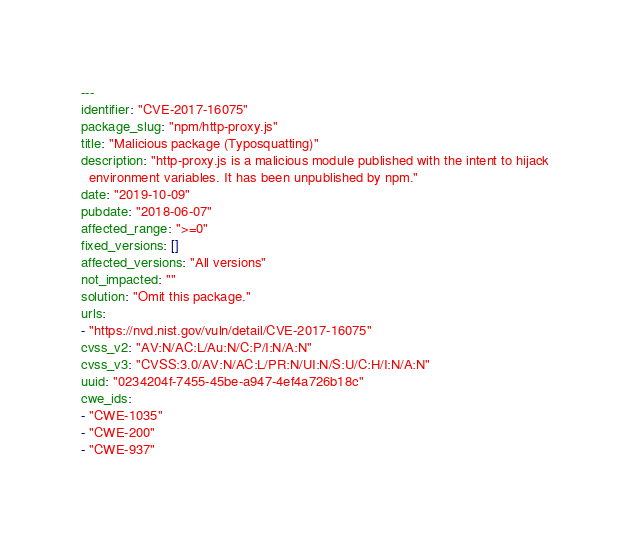Convert code to text. <code><loc_0><loc_0><loc_500><loc_500><_YAML_>---
identifier: "CVE-2017-16075"
package_slug: "npm/http-proxy.js"
title: "Malicious package (Typosquatting)"
description: "http-proxy.js is a malicious module published with the intent to hijack
  environment variables. It has been unpublished by npm."
date: "2019-10-09"
pubdate: "2018-06-07"
affected_range: ">=0"
fixed_versions: []
affected_versions: "All versions"
not_impacted: ""
solution: "Omit this package."
urls:
- "https://nvd.nist.gov/vuln/detail/CVE-2017-16075"
cvss_v2: "AV:N/AC:L/Au:N/C:P/I:N/A:N"
cvss_v3: "CVSS:3.0/AV:N/AC:L/PR:N/UI:N/S:U/C:H/I:N/A:N"
uuid: "0234204f-7455-45be-a947-4ef4a726b18c"
cwe_ids:
- "CWE-1035"
- "CWE-200"
- "CWE-937"
</code> 